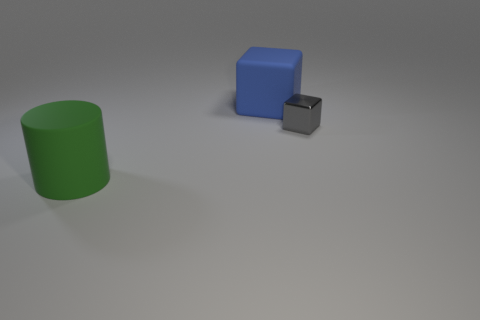What is the material of the thing to the right of the big rubber object on the right side of the large cylinder?
Offer a very short reply. Metal. Are there the same number of gray shiny objects behind the gray metallic thing and gray blocks?
Offer a terse response. No. Is there anything else that is made of the same material as the big blue thing?
Make the answer very short. Yes. There is a object in front of the metallic cube; is it the same color as the large object that is behind the tiny gray thing?
Offer a very short reply. No. What number of things are both to the left of the small gray block and in front of the big matte cube?
Your answer should be compact. 1. What number of other things are there of the same shape as the big green matte object?
Offer a very short reply. 0. Is the number of blocks in front of the small gray metallic block greater than the number of tiny things?
Give a very brief answer. No. The rubber object that is behind the matte cylinder is what color?
Give a very brief answer. Blue. How many matte objects are small objects or cubes?
Ensure brevity in your answer.  1. Is there a large blue cube that is behind the cube that is on the right side of the large matte object right of the big green cylinder?
Offer a terse response. Yes. 